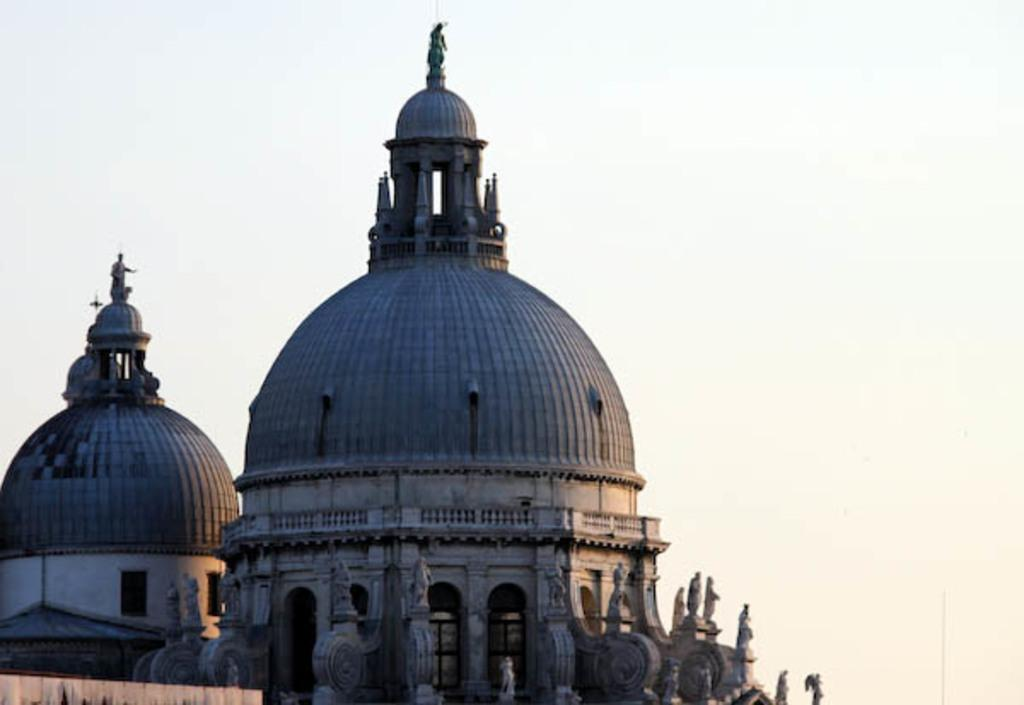What structures are located on the left side of the image? There are two tombs on the left side of the image. What can be seen in the background of the image? The sky is visible in the background of the image. Where can the receipt for the tombs be found in the image? There is no receipt present in the image, as it is a photograph of tombs and the sky. How many kittens are playing near the tombs in the image? There are no kittens present in the image; it only features tombs and the sky. 